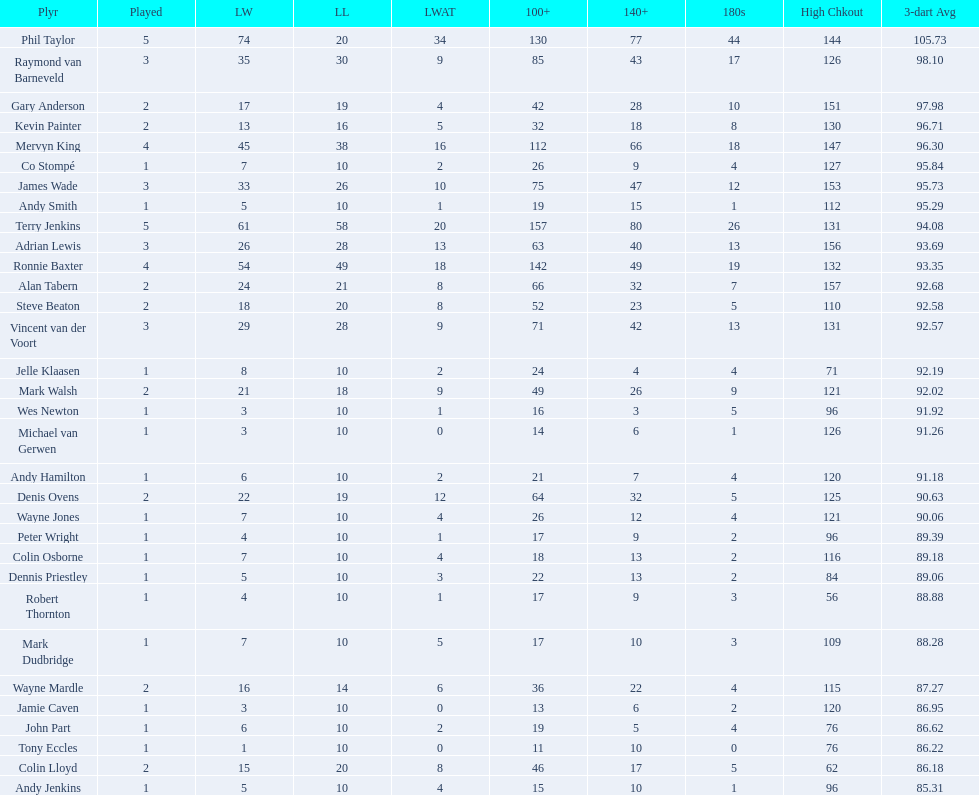Which player has his high checkout as 116? Colin Osborne. 